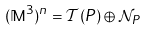Convert formula to latex. <formula><loc_0><loc_0><loc_500><loc_500>( \mathbb { M } ^ { 3 } ) ^ { n } = \mathcal { T } ( P ) \oplus \mathcal { N } _ { P }</formula> 